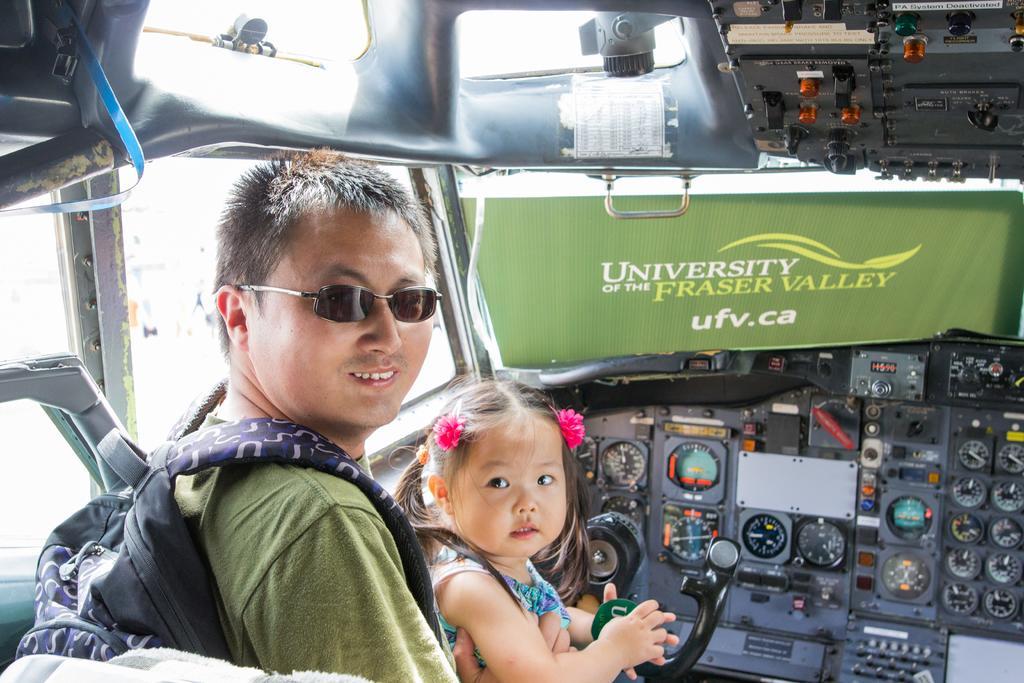Could you give a brief overview of what you see in this image? In the picture I can see a man and a girl are sitting. The man is wearing a bag, a t-shirt and shades. Here I can see some meters, buttons and some other objects. 